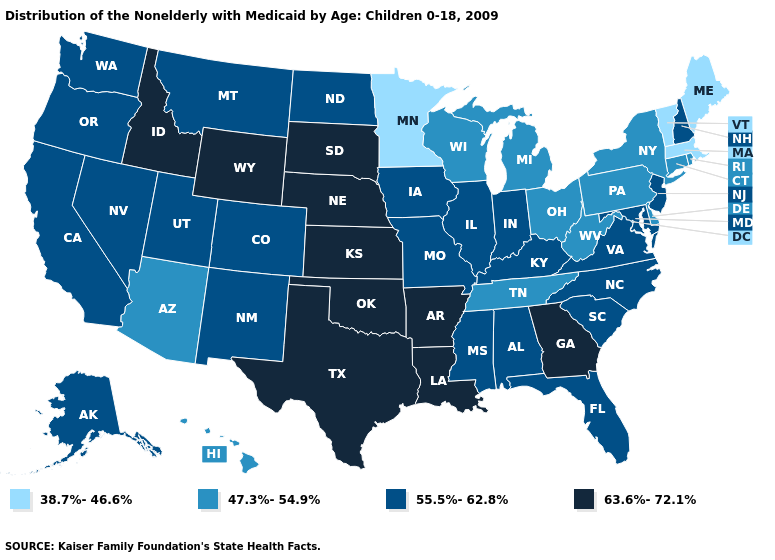What is the lowest value in states that border Utah?
Concise answer only. 47.3%-54.9%. What is the highest value in the USA?
Answer briefly. 63.6%-72.1%. Which states hav the highest value in the South?
Give a very brief answer. Arkansas, Georgia, Louisiana, Oklahoma, Texas. Which states have the lowest value in the Northeast?
Short answer required. Maine, Massachusetts, Vermont. Name the states that have a value in the range 38.7%-46.6%?
Short answer required. Maine, Massachusetts, Minnesota, Vermont. Name the states that have a value in the range 55.5%-62.8%?
Be succinct. Alabama, Alaska, California, Colorado, Florida, Illinois, Indiana, Iowa, Kentucky, Maryland, Mississippi, Missouri, Montana, Nevada, New Hampshire, New Jersey, New Mexico, North Carolina, North Dakota, Oregon, South Carolina, Utah, Virginia, Washington. Does Alaska have the lowest value in the West?
Answer briefly. No. Name the states that have a value in the range 38.7%-46.6%?
Short answer required. Maine, Massachusetts, Minnesota, Vermont. Does Connecticut have a higher value than Maine?
Be succinct. Yes. Among the states that border Virginia , does North Carolina have the lowest value?
Write a very short answer. No. Name the states that have a value in the range 38.7%-46.6%?
Give a very brief answer. Maine, Massachusetts, Minnesota, Vermont. What is the value of Massachusetts?
Concise answer only. 38.7%-46.6%. Name the states that have a value in the range 63.6%-72.1%?
Keep it brief. Arkansas, Georgia, Idaho, Kansas, Louisiana, Nebraska, Oklahoma, South Dakota, Texas, Wyoming. Name the states that have a value in the range 38.7%-46.6%?
Answer briefly. Maine, Massachusetts, Minnesota, Vermont. Among the states that border California , which have the highest value?
Keep it brief. Nevada, Oregon. 